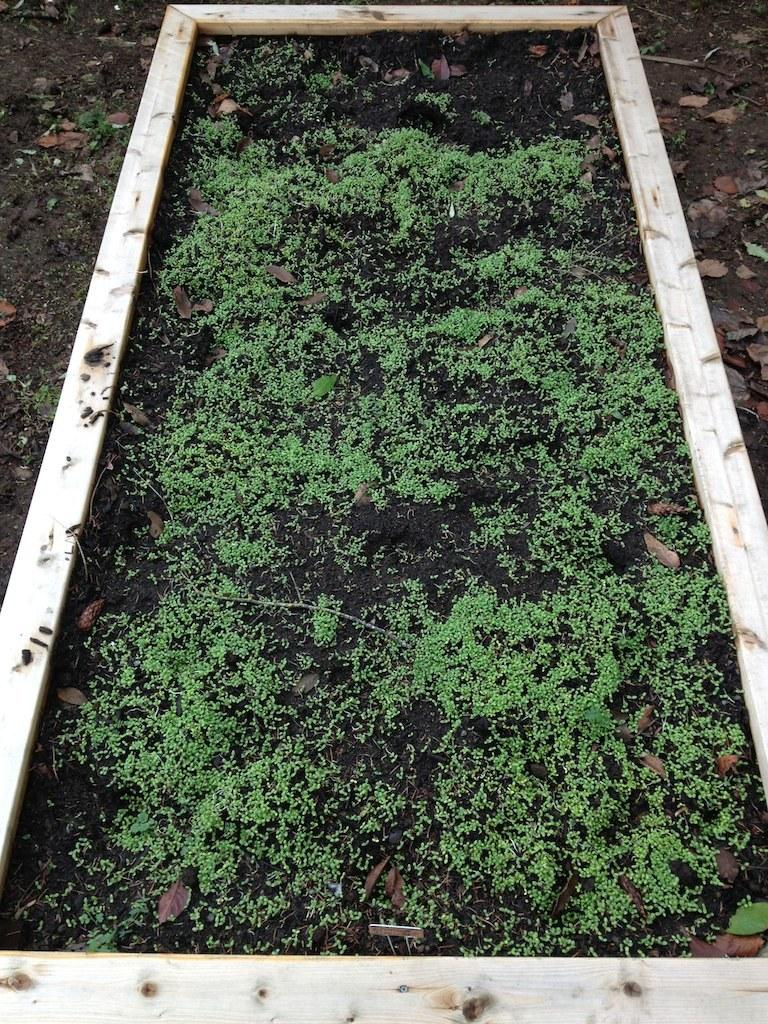What type of vegetation is in the center of the image? There is grass in the center of the image. How many mice are exchanging food in the scarecrow's hat in the image? There are no mice or scarecrow present in the image; it only features grass in the center. 